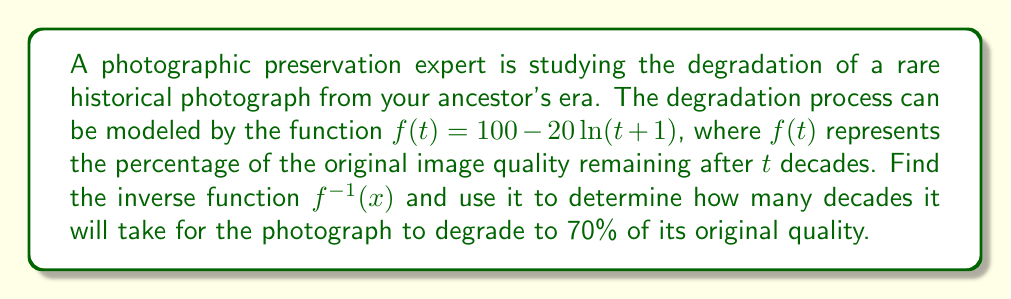Can you solve this math problem? To solve this problem, we need to follow these steps:

1) First, let's find the inverse function $f^{-1}(x)$:

   Start with $f(t) = 100 - 20\ln(t+1)$
   Let $x = f(t)$, so $x = 100 - 20\ln(t+1)$

2) Now, solve for $t$:
   
   $x - 100 = -20\ln(t+1)$
   $\frac{100-x}{20} = \ln(t+1)$
   $e^{\frac{100-x}{20}} = t+1$
   $e^{\frac{100-x}{20}} - 1 = t$

3) Therefore, the inverse function is:

   $f^{-1}(x) = e^{\frac{100-x}{20}} - 1$

4) To find how long it takes for the photograph to degrade to 70% quality, we need to calculate $f^{-1}(70)$:

   $f^{-1}(70) = e^{\frac{100-70}{20}} - 1$
               $= e^{\frac{30}{20}} - 1$
               $= e^{1.5} - 1$
               $\approx 3.4816$

5) This result is in decades, so we can round to the nearest tenth of a decade.
Answer: The inverse function is $f^{-1}(x) = e^{\frac{100-x}{20}} - 1$. It will take approximately 3.5 decades for the photograph to degrade to 70% of its original quality. 